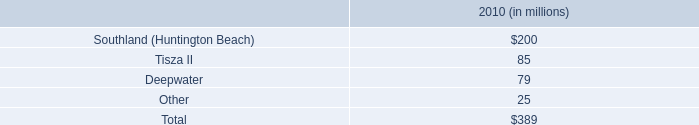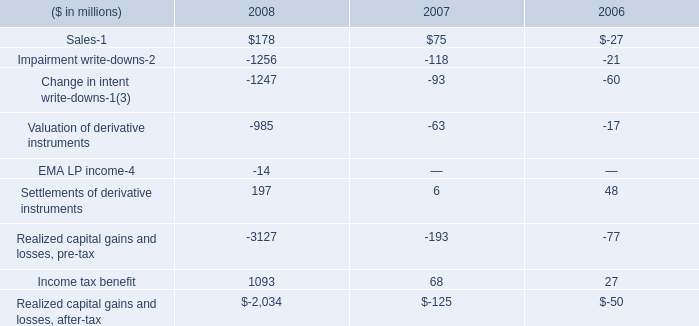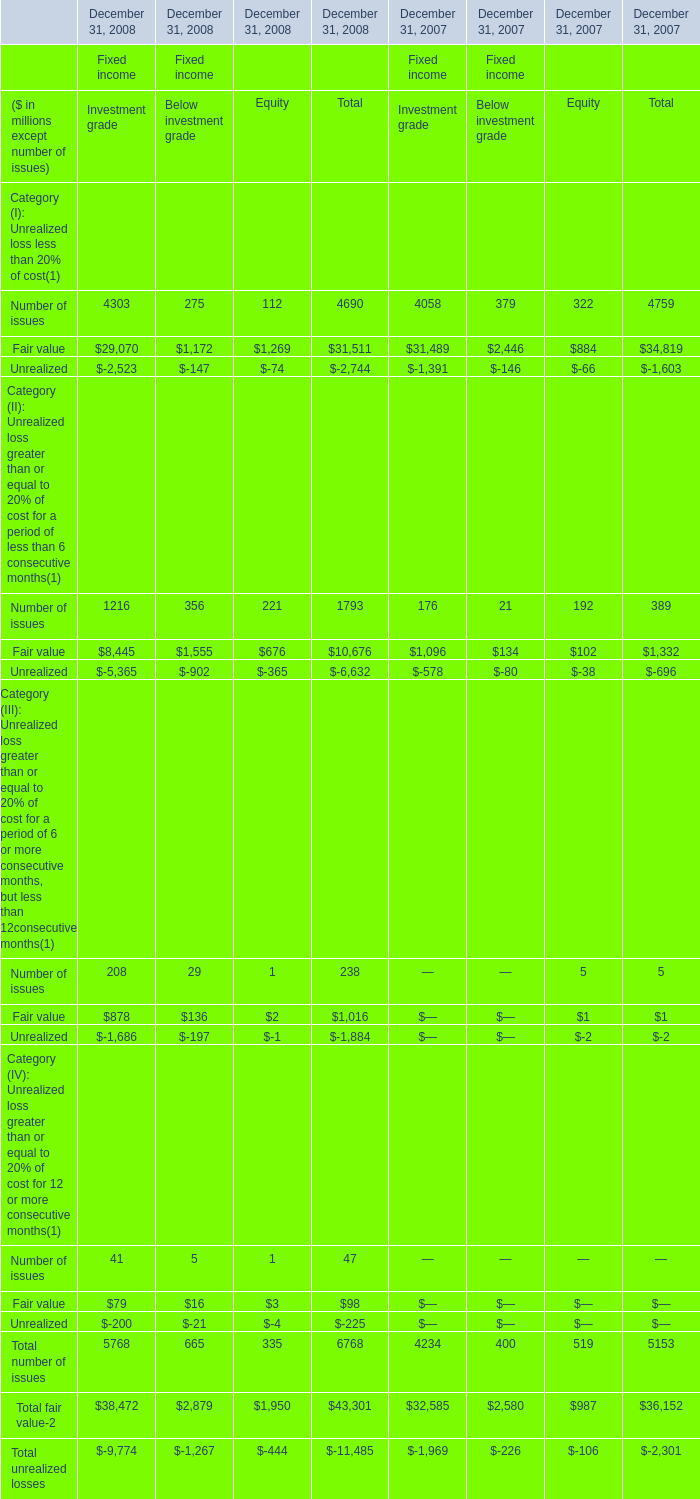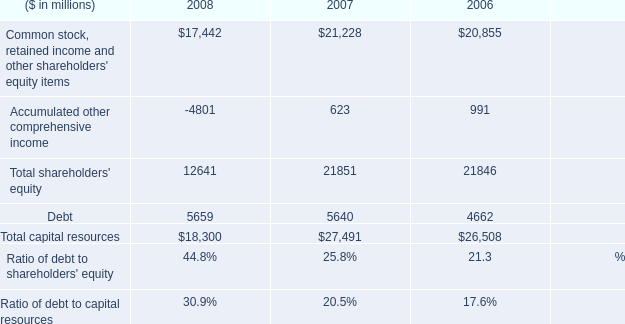Which element has the second largest number in 2008 for Investment grade? 
Answer: Fair value. 